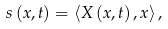Convert formula to latex. <formula><loc_0><loc_0><loc_500><loc_500>s \left ( x , t \right ) = \left < X \left ( x , t \right ) , x \right > ,</formula> 